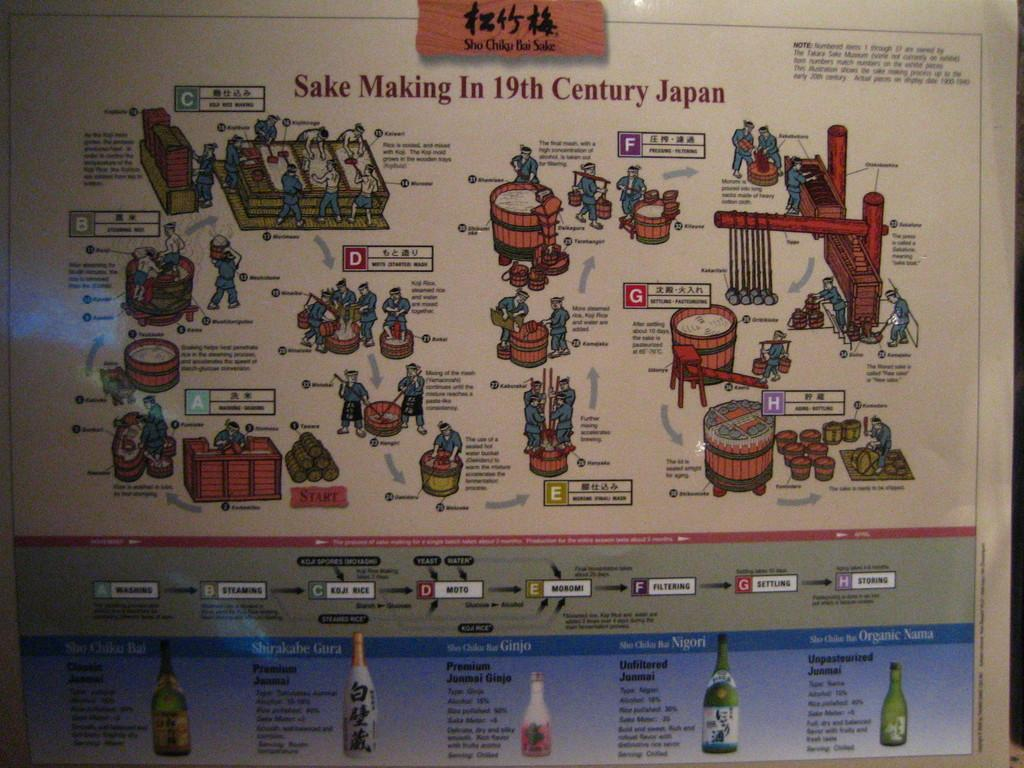Provide a one-sentence caption for the provided image. A poster that diagrams the Making of Sake in the 19th century in Japan. 